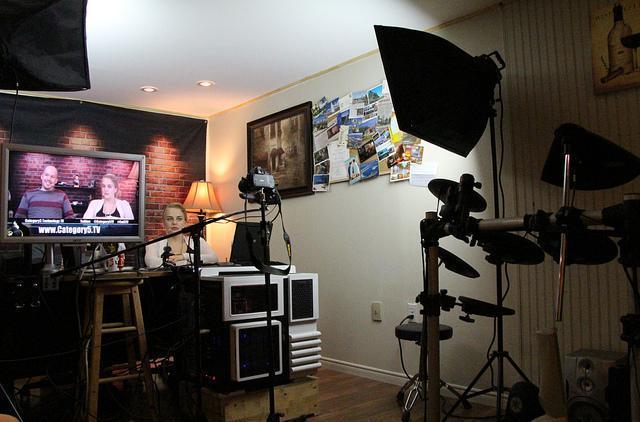How many people can be seen on the screen?
Give a very brief answer. 2. How many giraffes are there?
Give a very brief answer. 0. 